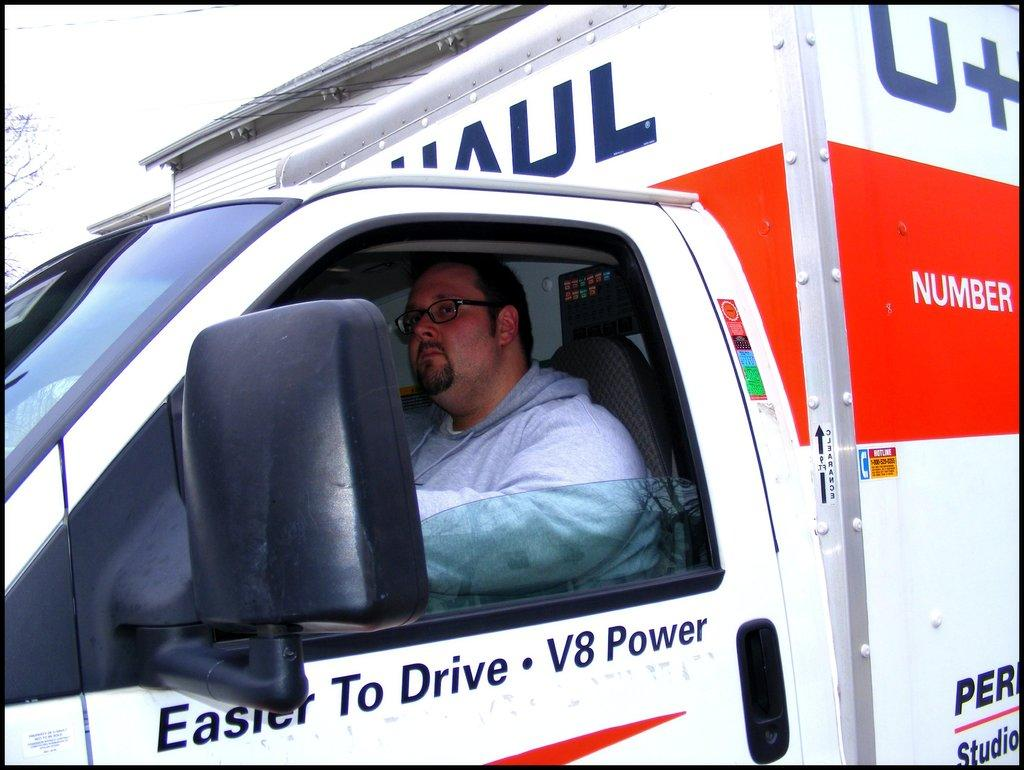What is the main subject of the image? There is a vehicle in the image. Who or what is inside the vehicle? A person is sitting in the vehicle. What can be seen on the left side of the image? There are branches of a tree on the left side of the image. Where is the text located in the image? There is some text at the right bottom of the image. What type of laborer is working on the cover of the vehicle in the image? There is no laborer or cover present in the image. What request is being made by the person in the vehicle in the image? There is no indication of a request being made by the person in the vehicle in the image. 